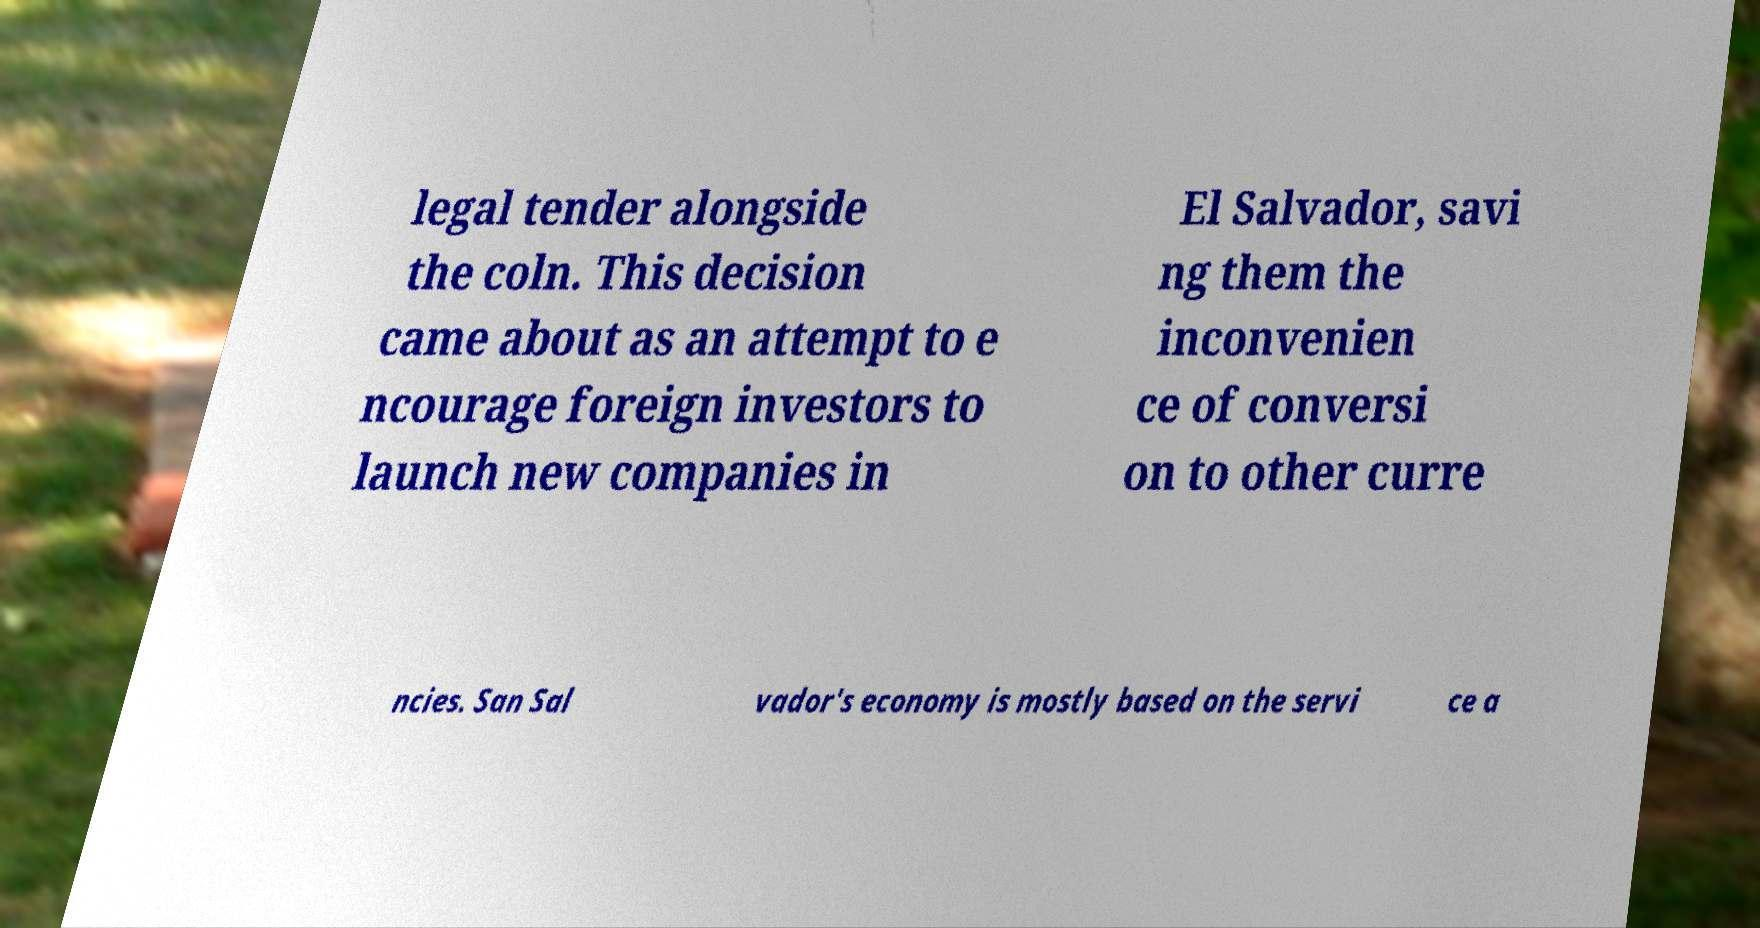Can you read and provide the text displayed in the image?This photo seems to have some interesting text. Can you extract and type it out for me? legal tender alongside the coln. This decision came about as an attempt to e ncourage foreign investors to launch new companies in El Salvador, savi ng them the inconvenien ce of conversi on to other curre ncies. San Sal vador's economy is mostly based on the servi ce a 